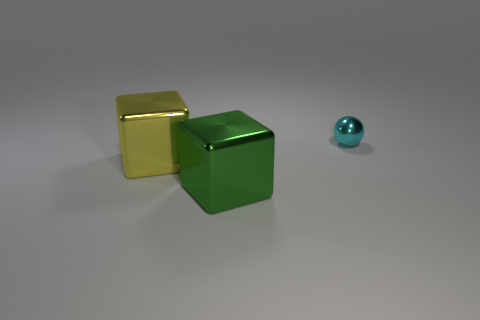What materials might the objects in the image be made of? Based on their appearance, it is plausible that the golden and green cubes may be made from a metallic material with a shiny, reflective surface, while the cyan ball also appears to be metallic due to its lustrous finish. 